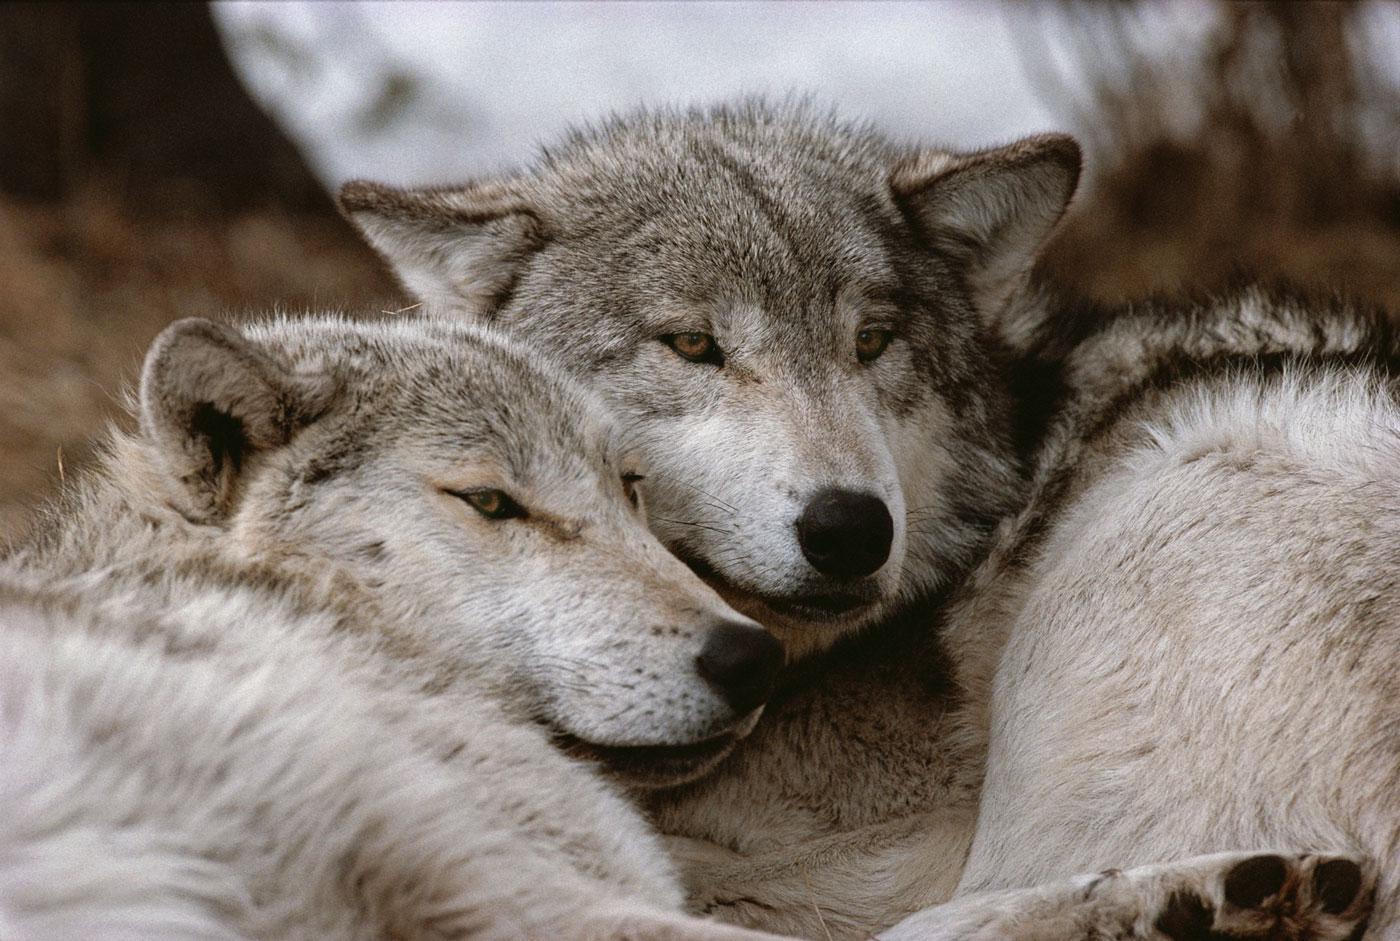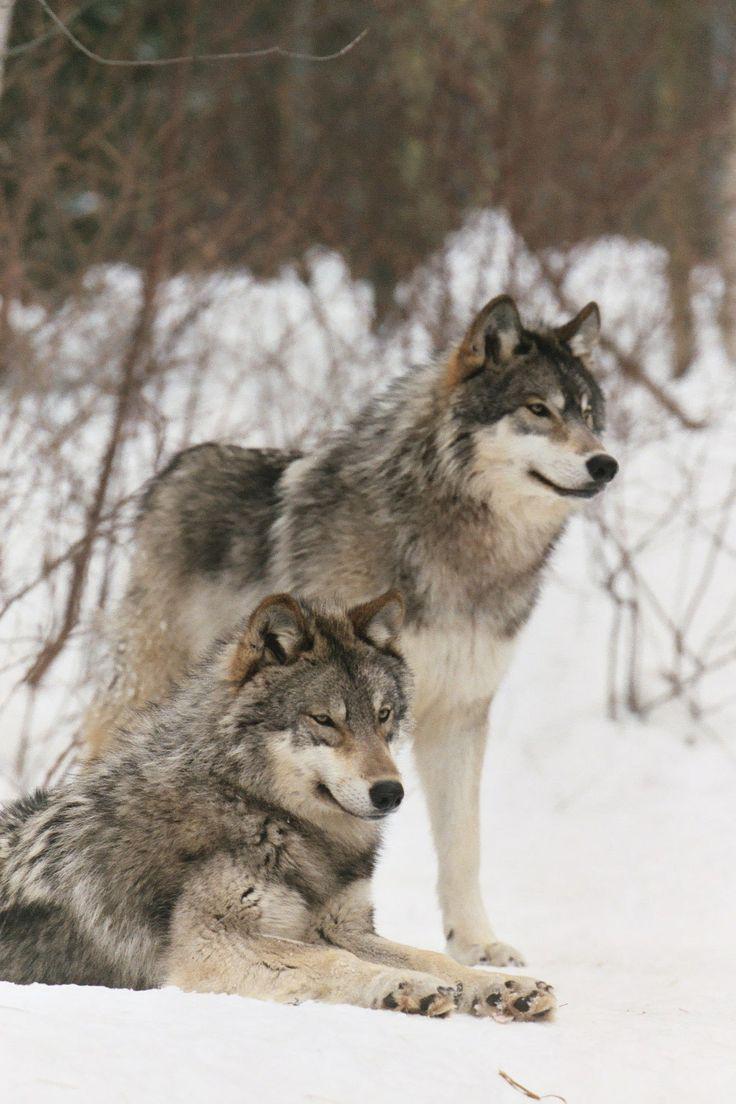The first image is the image on the left, the second image is the image on the right. Examine the images to the left and right. Is the description "An image shows two non-standing wolves with heads nuzzling close together." accurate? Answer yes or no. Yes. The first image is the image on the left, the second image is the image on the right. Evaluate the accuracy of this statement regarding the images: "a pair of wolves are cuddling with faces close". Is it true? Answer yes or no. Yes. 